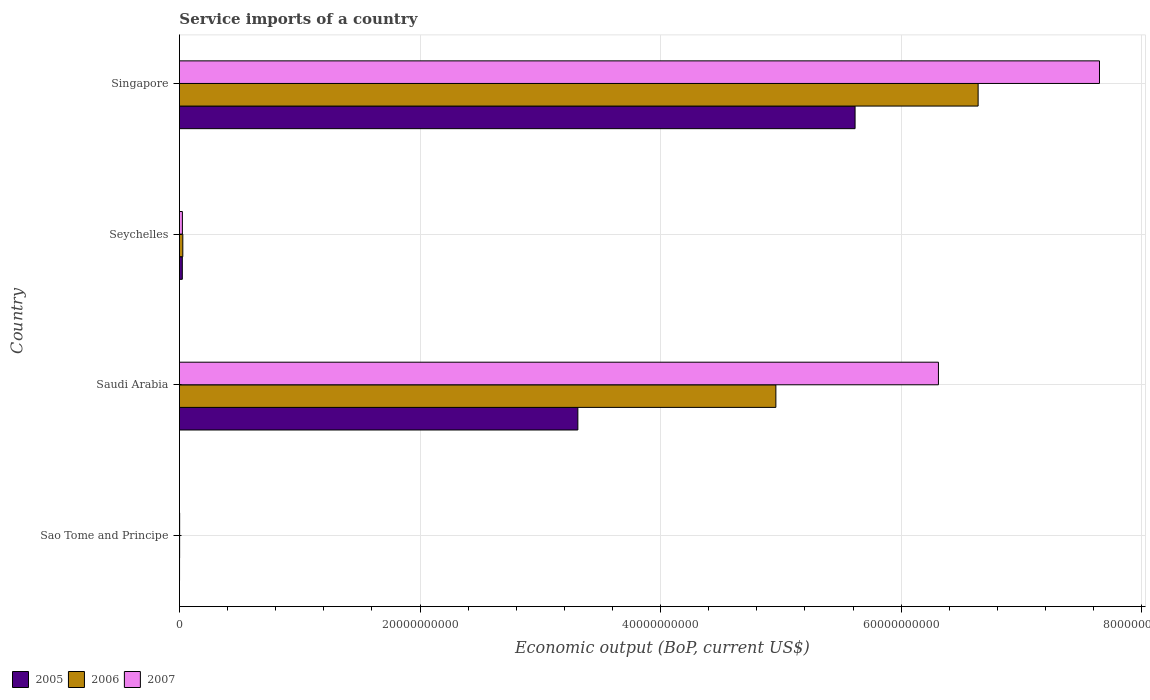Are the number of bars per tick equal to the number of legend labels?
Offer a very short reply. Yes. How many bars are there on the 3rd tick from the top?
Offer a very short reply. 3. What is the label of the 1st group of bars from the top?
Your response must be concise. Singapore. What is the service imports in 2005 in Saudi Arabia?
Offer a terse response. 3.31e+1. Across all countries, what is the maximum service imports in 2005?
Offer a terse response. 5.62e+1. Across all countries, what is the minimum service imports in 2007?
Provide a succinct answer. 1.87e+07. In which country was the service imports in 2007 maximum?
Offer a very short reply. Singapore. In which country was the service imports in 2005 minimum?
Keep it short and to the point. Sao Tome and Principe. What is the total service imports in 2006 in the graph?
Offer a very short reply. 1.16e+11. What is the difference between the service imports in 2005 in Seychelles and that in Singapore?
Your response must be concise. -5.59e+1. What is the difference between the service imports in 2005 in Singapore and the service imports in 2007 in Sao Tome and Principe?
Make the answer very short. 5.61e+1. What is the average service imports in 2007 per country?
Offer a terse response. 3.50e+1. What is the difference between the service imports in 2005 and service imports in 2007 in Saudi Arabia?
Keep it short and to the point. -3.00e+1. What is the ratio of the service imports in 2006 in Saudi Arabia to that in Seychelles?
Offer a very short reply. 175.36. Is the service imports in 2005 in Sao Tome and Principe less than that in Saudi Arabia?
Keep it short and to the point. Yes. Is the difference between the service imports in 2005 in Sao Tome and Principe and Singapore greater than the difference between the service imports in 2007 in Sao Tome and Principe and Singapore?
Your response must be concise. Yes. What is the difference between the highest and the second highest service imports in 2005?
Provide a succinct answer. 2.30e+1. What is the difference between the highest and the lowest service imports in 2005?
Provide a short and direct response. 5.62e+1. In how many countries, is the service imports in 2006 greater than the average service imports in 2006 taken over all countries?
Provide a succinct answer. 2. What does the 3rd bar from the bottom in Seychelles represents?
Offer a terse response. 2007. How many bars are there?
Offer a terse response. 12. How many countries are there in the graph?
Provide a succinct answer. 4. What is the difference between two consecutive major ticks on the X-axis?
Your response must be concise. 2.00e+1. Are the values on the major ticks of X-axis written in scientific E-notation?
Provide a short and direct response. No. Does the graph contain grids?
Provide a short and direct response. Yes. Where does the legend appear in the graph?
Offer a very short reply. Bottom left. How many legend labels are there?
Ensure brevity in your answer.  3. What is the title of the graph?
Your answer should be very brief. Service imports of a country. What is the label or title of the X-axis?
Offer a very short reply. Economic output (BoP, current US$). What is the label or title of the Y-axis?
Your answer should be very brief. Country. What is the Economic output (BoP, current US$) of 2005 in Sao Tome and Principe?
Offer a very short reply. 1.11e+07. What is the Economic output (BoP, current US$) of 2006 in Sao Tome and Principe?
Your answer should be very brief. 1.78e+07. What is the Economic output (BoP, current US$) in 2007 in Sao Tome and Principe?
Offer a very short reply. 1.87e+07. What is the Economic output (BoP, current US$) of 2005 in Saudi Arabia?
Ensure brevity in your answer.  3.31e+1. What is the Economic output (BoP, current US$) in 2006 in Saudi Arabia?
Your response must be concise. 4.96e+1. What is the Economic output (BoP, current US$) of 2007 in Saudi Arabia?
Your answer should be very brief. 6.31e+1. What is the Economic output (BoP, current US$) in 2005 in Seychelles?
Offer a terse response. 2.40e+08. What is the Economic output (BoP, current US$) of 2006 in Seychelles?
Offer a terse response. 2.83e+08. What is the Economic output (BoP, current US$) in 2007 in Seychelles?
Offer a very short reply. 2.47e+08. What is the Economic output (BoP, current US$) in 2005 in Singapore?
Your response must be concise. 5.62e+1. What is the Economic output (BoP, current US$) of 2006 in Singapore?
Your response must be concise. 6.64e+1. What is the Economic output (BoP, current US$) in 2007 in Singapore?
Ensure brevity in your answer.  7.65e+1. Across all countries, what is the maximum Economic output (BoP, current US$) of 2005?
Provide a succinct answer. 5.62e+1. Across all countries, what is the maximum Economic output (BoP, current US$) in 2006?
Your response must be concise. 6.64e+1. Across all countries, what is the maximum Economic output (BoP, current US$) in 2007?
Give a very brief answer. 7.65e+1. Across all countries, what is the minimum Economic output (BoP, current US$) of 2005?
Ensure brevity in your answer.  1.11e+07. Across all countries, what is the minimum Economic output (BoP, current US$) in 2006?
Make the answer very short. 1.78e+07. Across all countries, what is the minimum Economic output (BoP, current US$) in 2007?
Ensure brevity in your answer.  1.87e+07. What is the total Economic output (BoP, current US$) of 2005 in the graph?
Offer a very short reply. 8.95e+1. What is the total Economic output (BoP, current US$) in 2006 in the graph?
Offer a very short reply. 1.16e+11. What is the total Economic output (BoP, current US$) in 2007 in the graph?
Keep it short and to the point. 1.40e+11. What is the difference between the Economic output (BoP, current US$) in 2005 in Sao Tome and Principe and that in Saudi Arabia?
Ensure brevity in your answer.  -3.31e+1. What is the difference between the Economic output (BoP, current US$) of 2006 in Sao Tome and Principe and that in Saudi Arabia?
Offer a very short reply. -4.96e+1. What is the difference between the Economic output (BoP, current US$) in 2007 in Sao Tome and Principe and that in Saudi Arabia?
Your answer should be compact. -6.31e+1. What is the difference between the Economic output (BoP, current US$) of 2005 in Sao Tome and Principe and that in Seychelles?
Offer a very short reply. -2.29e+08. What is the difference between the Economic output (BoP, current US$) in 2006 in Sao Tome and Principe and that in Seychelles?
Give a very brief answer. -2.65e+08. What is the difference between the Economic output (BoP, current US$) of 2007 in Sao Tome and Principe and that in Seychelles?
Your response must be concise. -2.28e+08. What is the difference between the Economic output (BoP, current US$) of 2005 in Sao Tome and Principe and that in Singapore?
Offer a very short reply. -5.62e+1. What is the difference between the Economic output (BoP, current US$) of 2006 in Sao Tome and Principe and that in Singapore?
Your answer should be compact. -6.64e+1. What is the difference between the Economic output (BoP, current US$) of 2007 in Sao Tome and Principe and that in Singapore?
Your answer should be very brief. -7.65e+1. What is the difference between the Economic output (BoP, current US$) of 2005 in Saudi Arabia and that in Seychelles?
Your response must be concise. 3.29e+1. What is the difference between the Economic output (BoP, current US$) of 2006 in Saudi Arabia and that in Seychelles?
Keep it short and to the point. 4.93e+1. What is the difference between the Economic output (BoP, current US$) of 2007 in Saudi Arabia and that in Seychelles?
Your answer should be very brief. 6.28e+1. What is the difference between the Economic output (BoP, current US$) of 2005 in Saudi Arabia and that in Singapore?
Your answer should be compact. -2.30e+1. What is the difference between the Economic output (BoP, current US$) in 2006 in Saudi Arabia and that in Singapore?
Provide a short and direct response. -1.68e+1. What is the difference between the Economic output (BoP, current US$) in 2007 in Saudi Arabia and that in Singapore?
Your response must be concise. -1.34e+1. What is the difference between the Economic output (BoP, current US$) of 2005 in Seychelles and that in Singapore?
Provide a short and direct response. -5.59e+1. What is the difference between the Economic output (BoP, current US$) of 2006 in Seychelles and that in Singapore?
Provide a succinct answer. -6.61e+1. What is the difference between the Economic output (BoP, current US$) of 2007 in Seychelles and that in Singapore?
Provide a succinct answer. -7.62e+1. What is the difference between the Economic output (BoP, current US$) of 2005 in Sao Tome and Principe and the Economic output (BoP, current US$) of 2006 in Saudi Arabia?
Provide a short and direct response. -4.96e+1. What is the difference between the Economic output (BoP, current US$) in 2005 in Sao Tome and Principe and the Economic output (BoP, current US$) in 2007 in Saudi Arabia?
Offer a terse response. -6.31e+1. What is the difference between the Economic output (BoP, current US$) of 2006 in Sao Tome and Principe and the Economic output (BoP, current US$) of 2007 in Saudi Arabia?
Give a very brief answer. -6.31e+1. What is the difference between the Economic output (BoP, current US$) of 2005 in Sao Tome and Principe and the Economic output (BoP, current US$) of 2006 in Seychelles?
Offer a very short reply. -2.72e+08. What is the difference between the Economic output (BoP, current US$) of 2005 in Sao Tome and Principe and the Economic output (BoP, current US$) of 2007 in Seychelles?
Your answer should be very brief. -2.36e+08. What is the difference between the Economic output (BoP, current US$) of 2006 in Sao Tome and Principe and the Economic output (BoP, current US$) of 2007 in Seychelles?
Your answer should be very brief. -2.29e+08. What is the difference between the Economic output (BoP, current US$) in 2005 in Sao Tome and Principe and the Economic output (BoP, current US$) in 2006 in Singapore?
Your response must be concise. -6.64e+1. What is the difference between the Economic output (BoP, current US$) in 2005 in Sao Tome and Principe and the Economic output (BoP, current US$) in 2007 in Singapore?
Provide a short and direct response. -7.65e+1. What is the difference between the Economic output (BoP, current US$) of 2006 in Sao Tome and Principe and the Economic output (BoP, current US$) of 2007 in Singapore?
Give a very brief answer. -7.65e+1. What is the difference between the Economic output (BoP, current US$) of 2005 in Saudi Arabia and the Economic output (BoP, current US$) of 2006 in Seychelles?
Make the answer very short. 3.28e+1. What is the difference between the Economic output (BoP, current US$) of 2005 in Saudi Arabia and the Economic output (BoP, current US$) of 2007 in Seychelles?
Offer a very short reply. 3.29e+1. What is the difference between the Economic output (BoP, current US$) of 2006 in Saudi Arabia and the Economic output (BoP, current US$) of 2007 in Seychelles?
Your response must be concise. 4.93e+1. What is the difference between the Economic output (BoP, current US$) of 2005 in Saudi Arabia and the Economic output (BoP, current US$) of 2006 in Singapore?
Provide a succinct answer. -3.33e+1. What is the difference between the Economic output (BoP, current US$) of 2005 in Saudi Arabia and the Economic output (BoP, current US$) of 2007 in Singapore?
Provide a short and direct response. -4.34e+1. What is the difference between the Economic output (BoP, current US$) in 2006 in Saudi Arabia and the Economic output (BoP, current US$) in 2007 in Singapore?
Make the answer very short. -2.69e+1. What is the difference between the Economic output (BoP, current US$) in 2005 in Seychelles and the Economic output (BoP, current US$) in 2006 in Singapore?
Offer a very short reply. -6.62e+1. What is the difference between the Economic output (BoP, current US$) in 2005 in Seychelles and the Economic output (BoP, current US$) in 2007 in Singapore?
Give a very brief answer. -7.62e+1. What is the difference between the Economic output (BoP, current US$) of 2006 in Seychelles and the Economic output (BoP, current US$) of 2007 in Singapore?
Ensure brevity in your answer.  -7.62e+1. What is the average Economic output (BoP, current US$) in 2005 per country?
Provide a short and direct response. 2.24e+1. What is the average Economic output (BoP, current US$) of 2006 per country?
Make the answer very short. 2.91e+1. What is the average Economic output (BoP, current US$) of 2007 per country?
Ensure brevity in your answer.  3.50e+1. What is the difference between the Economic output (BoP, current US$) of 2005 and Economic output (BoP, current US$) of 2006 in Sao Tome and Principe?
Make the answer very short. -6.70e+06. What is the difference between the Economic output (BoP, current US$) of 2005 and Economic output (BoP, current US$) of 2007 in Sao Tome and Principe?
Your answer should be very brief. -7.61e+06. What is the difference between the Economic output (BoP, current US$) in 2006 and Economic output (BoP, current US$) in 2007 in Sao Tome and Principe?
Provide a succinct answer. -9.06e+05. What is the difference between the Economic output (BoP, current US$) in 2005 and Economic output (BoP, current US$) in 2006 in Saudi Arabia?
Ensure brevity in your answer.  -1.65e+1. What is the difference between the Economic output (BoP, current US$) in 2005 and Economic output (BoP, current US$) in 2007 in Saudi Arabia?
Your answer should be very brief. -3.00e+1. What is the difference between the Economic output (BoP, current US$) in 2006 and Economic output (BoP, current US$) in 2007 in Saudi Arabia?
Provide a succinct answer. -1.35e+1. What is the difference between the Economic output (BoP, current US$) of 2005 and Economic output (BoP, current US$) of 2006 in Seychelles?
Provide a short and direct response. -4.24e+07. What is the difference between the Economic output (BoP, current US$) in 2005 and Economic output (BoP, current US$) in 2007 in Seychelles?
Provide a short and direct response. -6.43e+06. What is the difference between the Economic output (BoP, current US$) of 2006 and Economic output (BoP, current US$) of 2007 in Seychelles?
Ensure brevity in your answer.  3.60e+07. What is the difference between the Economic output (BoP, current US$) in 2005 and Economic output (BoP, current US$) in 2006 in Singapore?
Make the answer very short. -1.02e+1. What is the difference between the Economic output (BoP, current US$) in 2005 and Economic output (BoP, current US$) in 2007 in Singapore?
Provide a succinct answer. -2.03e+1. What is the difference between the Economic output (BoP, current US$) of 2006 and Economic output (BoP, current US$) of 2007 in Singapore?
Your answer should be very brief. -1.01e+1. What is the ratio of the Economic output (BoP, current US$) in 2006 in Sao Tome and Principe to that in Saudi Arabia?
Provide a short and direct response. 0. What is the ratio of the Economic output (BoP, current US$) in 2005 in Sao Tome and Principe to that in Seychelles?
Your answer should be very brief. 0.05. What is the ratio of the Economic output (BoP, current US$) of 2006 in Sao Tome and Principe to that in Seychelles?
Provide a succinct answer. 0.06. What is the ratio of the Economic output (BoP, current US$) of 2007 in Sao Tome and Principe to that in Seychelles?
Make the answer very short. 0.08. What is the ratio of the Economic output (BoP, current US$) of 2005 in Sao Tome and Principe to that in Singapore?
Your response must be concise. 0. What is the ratio of the Economic output (BoP, current US$) in 2007 in Sao Tome and Principe to that in Singapore?
Your response must be concise. 0. What is the ratio of the Economic output (BoP, current US$) in 2005 in Saudi Arabia to that in Seychelles?
Ensure brevity in your answer.  137.81. What is the ratio of the Economic output (BoP, current US$) in 2006 in Saudi Arabia to that in Seychelles?
Keep it short and to the point. 175.36. What is the ratio of the Economic output (BoP, current US$) of 2007 in Saudi Arabia to that in Seychelles?
Your answer should be very brief. 255.68. What is the ratio of the Economic output (BoP, current US$) of 2005 in Saudi Arabia to that in Singapore?
Make the answer very short. 0.59. What is the ratio of the Economic output (BoP, current US$) in 2006 in Saudi Arabia to that in Singapore?
Make the answer very short. 0.75. What is the ratio of the Economic output (BoP, current US$) in 2007 in Saudi Arabia to that in Singapore?
Your response must be concise. 0.82. What is the ratio of the Economic output (BoP, current US$) of 2005 in Seychelles to that in Singapore?
Your answer should be very brief. 0. What is the ratio of the Economic output (BoP, current US$) in 2006 in Seychelles to that in Singapore?
Provide a short and direct response. 0. What is the ratio of the Economic output (BoP, current US$) of 2007 in Seychelles to that in Singapore?
Provide a succinct answer. 0. What is the difference between the highest and the second highest Economic output (BoP, current US$) in 2005?
Offer a terse response. 2.30e+1. What is the difference between the highest and the second highest Economic output (BoP, current US$) in 2006?
Provide a short and direct response. 1.68e+1. What is the difference between the highest and the second highest Economic output (BoP, current US$) in 2007?
Provide a succinct answer. 1.34e+1. What is the difference between the highest and the lowest Economic output (BoP, current US$) of 2005?
Provide a short and direct response. 5.62e+1. What is the difference between the highest and the lowest Economic output (BoP, current US$) of 2006?
Make the answer very short. 6.64e+1. What is the difference between the highest and the lowest Economic output (BoP, current US$) in 2007?
Offer a terse response. 7.65e+1. 